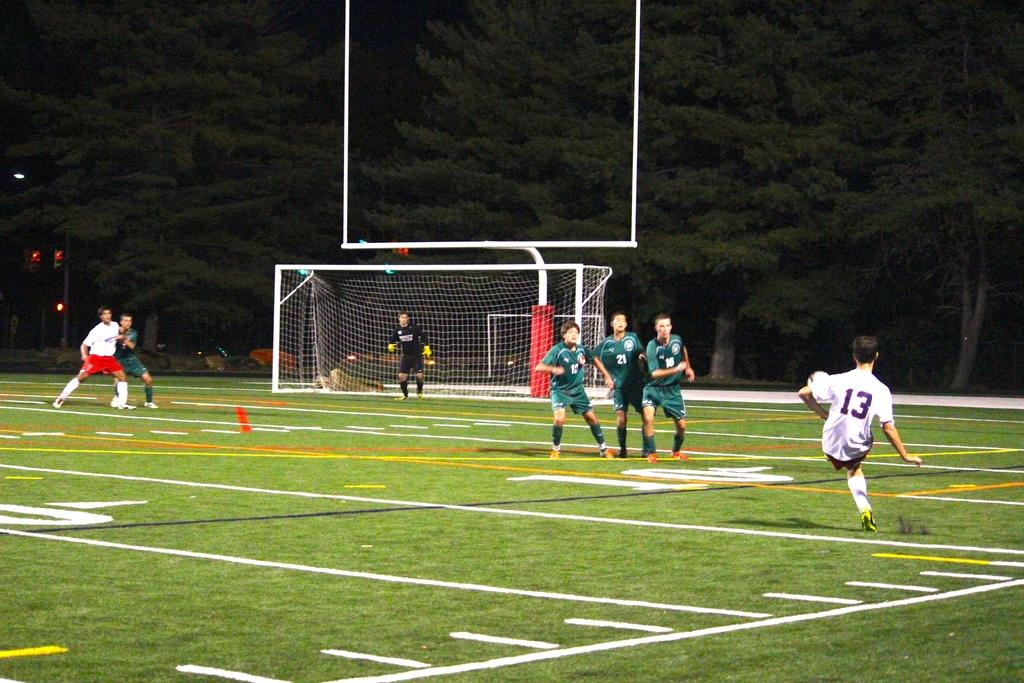<image>
Create a compact narrative representing the image presented. A soccer player number 13 about to deliver a kick. 